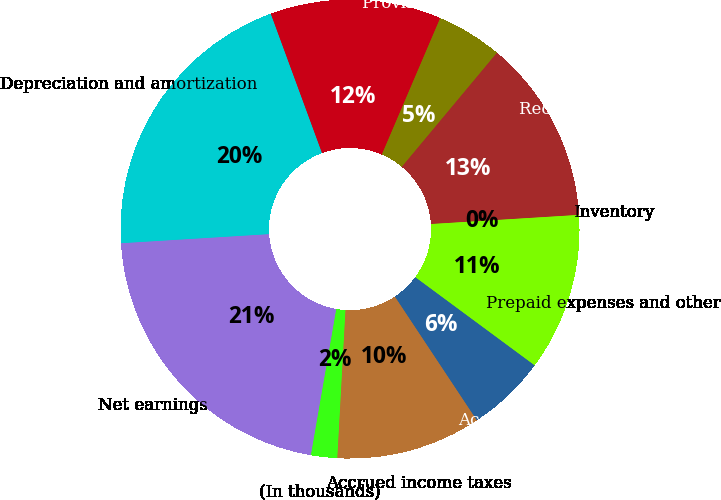<chart> <loc_0><loc_0><loc_500><loc_500><pie_chart><fcel>(In thousands)<fcel>Net earnings<fcel>Depreciation and amortization<fcel>Share-based compensation<fcel>Provision for deferred income<fcel>Receivables net<fcel>Inventory<fcel>Prepaid expenses and other<fcel>Accounts payable<fcel>Accrued income taxes<nl><fcel>1.86%<fcel>21.29%<fcel>20.37%<fcel>12.04%<fcel>4.63%<fcel>12.96%<fcel>0.0%<fcel>11.11%<fcel>5.56%<fcel>10.19%<nl></chart> 